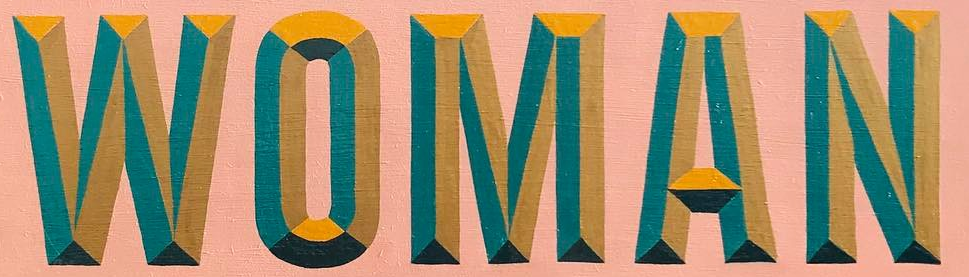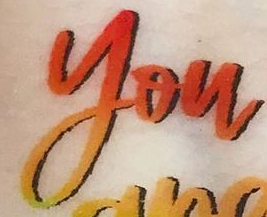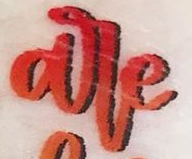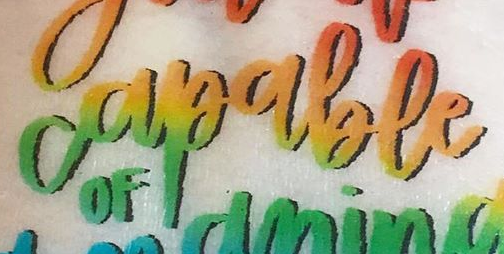What words can you see in these images in sequence, separated by a semicolon? WOMAN; you; are; capable 